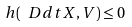Convert formula to latex. <formula><loc_0><loc_0><loc_500><loc_500>h ( \ D d t X , V ) \leq 0</formula> 